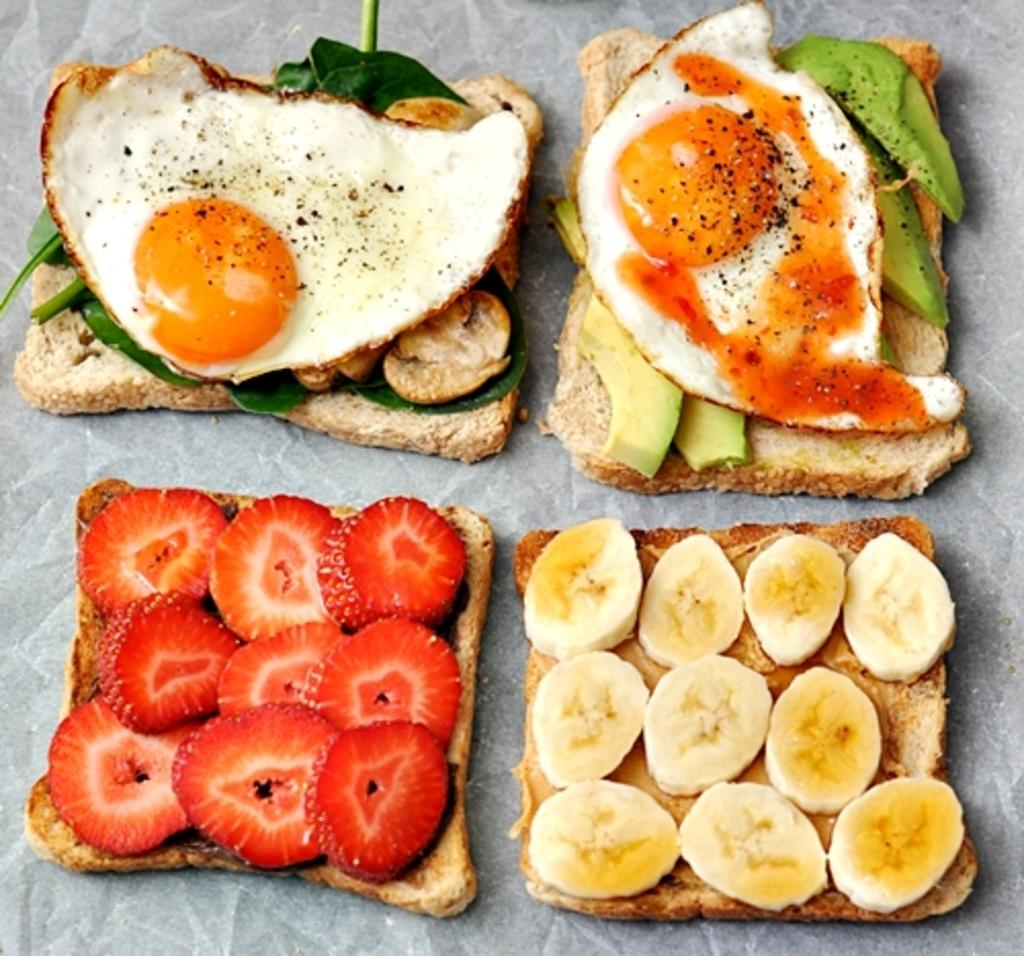What types of food items can be seen in the image? There are food items in the image, but their specific types cannot be determined from the provided facts. What colors are the food items in the image? The food items are in brown, red, cream, and green colors. What color is the background of the image? The background of the image is white. What store is selling the food items in the image? There is no information about a store in the image or the provided facts. 